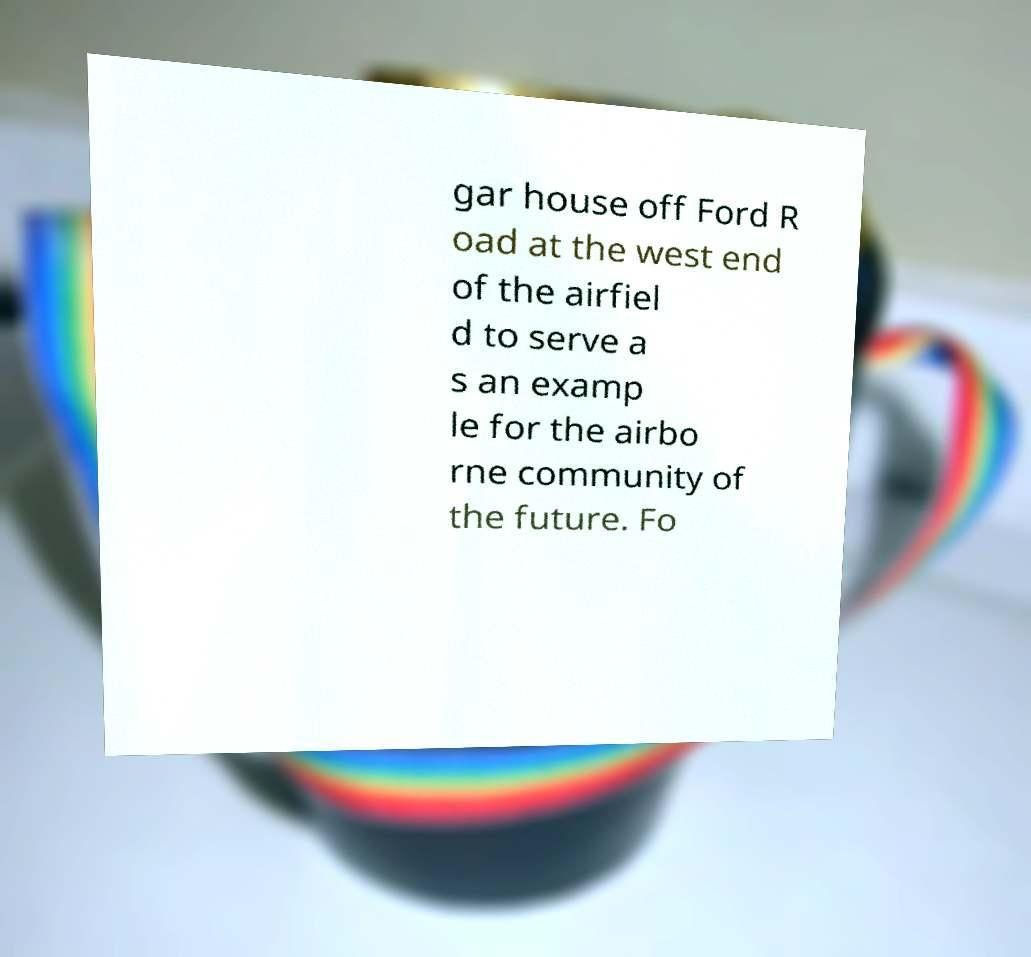Please identify and transcribe the text found in this image. gar house off Ford R oad at the west end of the airfiel d to serve a s an examp le for the airbo rne community of the future. Fo 